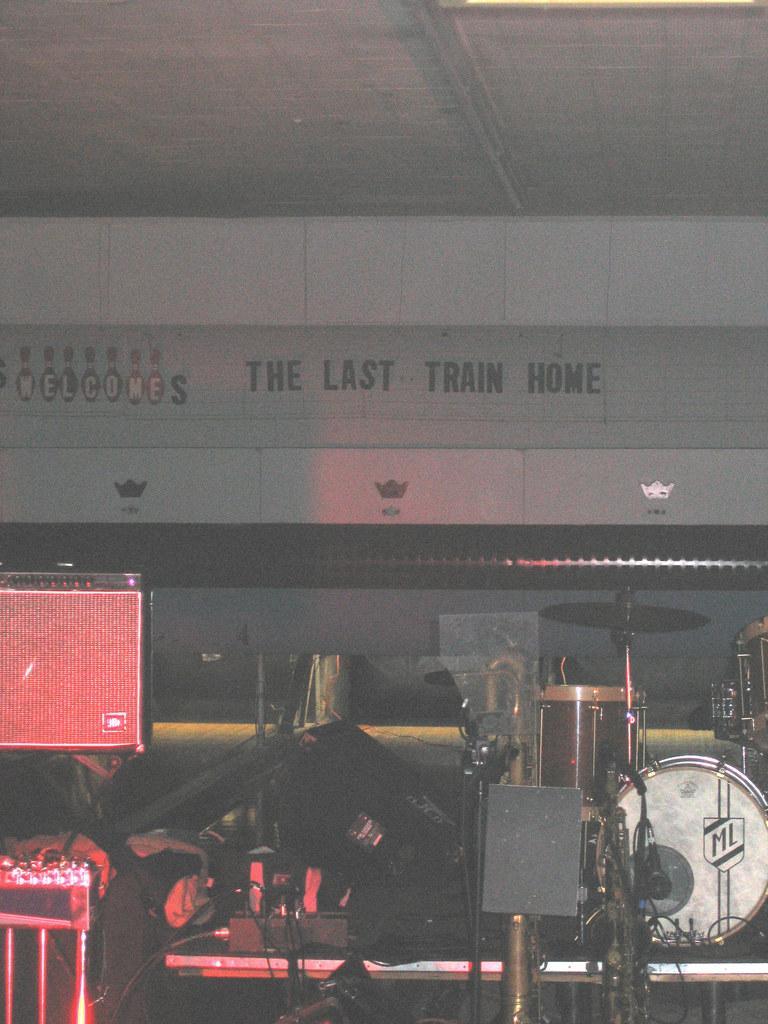Could you give a brief overview of what you see in this image? In this picture there is a music band placed on the stage. On the left side there is a music instrument. Behind we can see the white color roofing shed. 